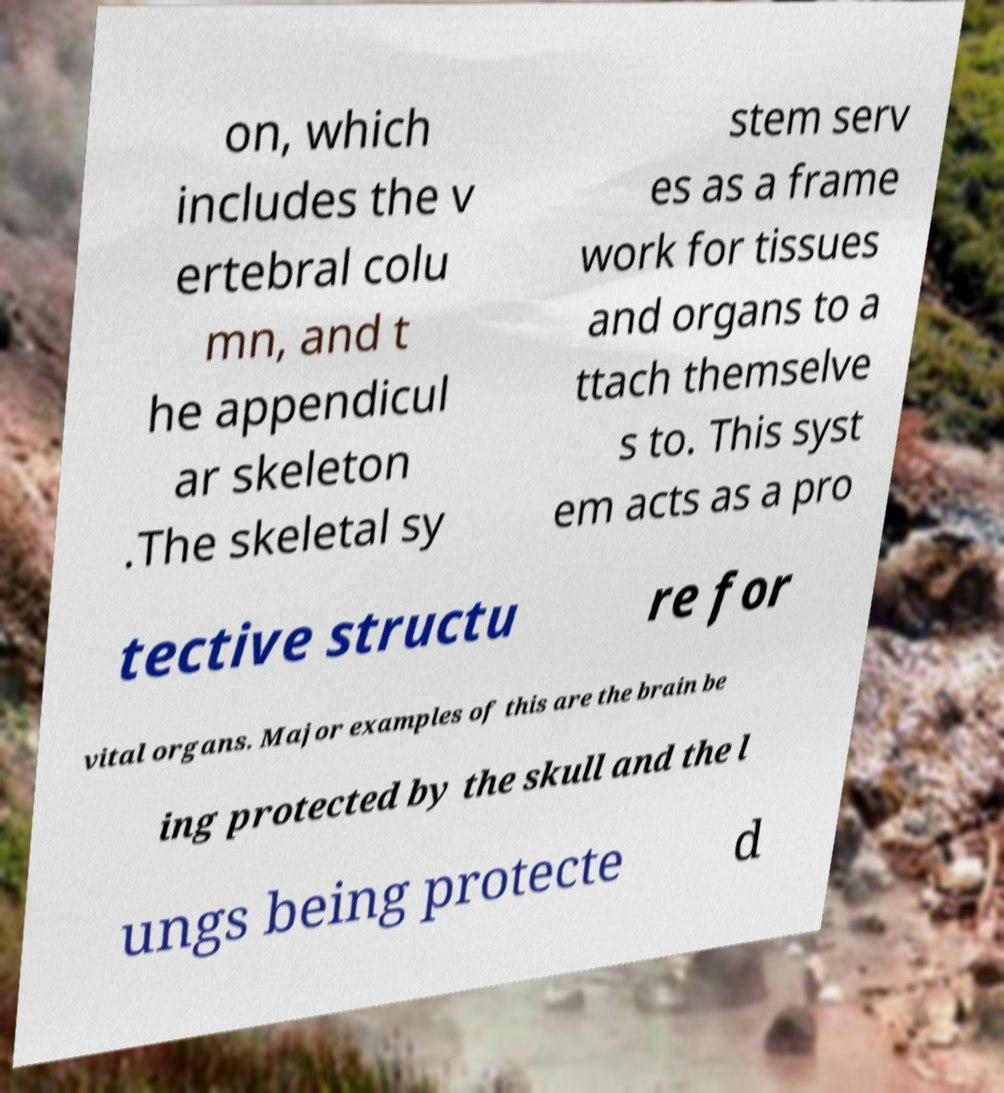For documentation purposes, I need the text within this image transcribed. Could you provide that? on, which includes the v ertebral colu mn, and t he appendicul ar skeleton .The skeletal sy stem serv es as a frame work for tissues and organs to a ttach themselve s to. This syst em acts as a pro tective structu re for vital organs. Major examples of this are the brain be ing protected by the skull and the l ungs being protecte d 